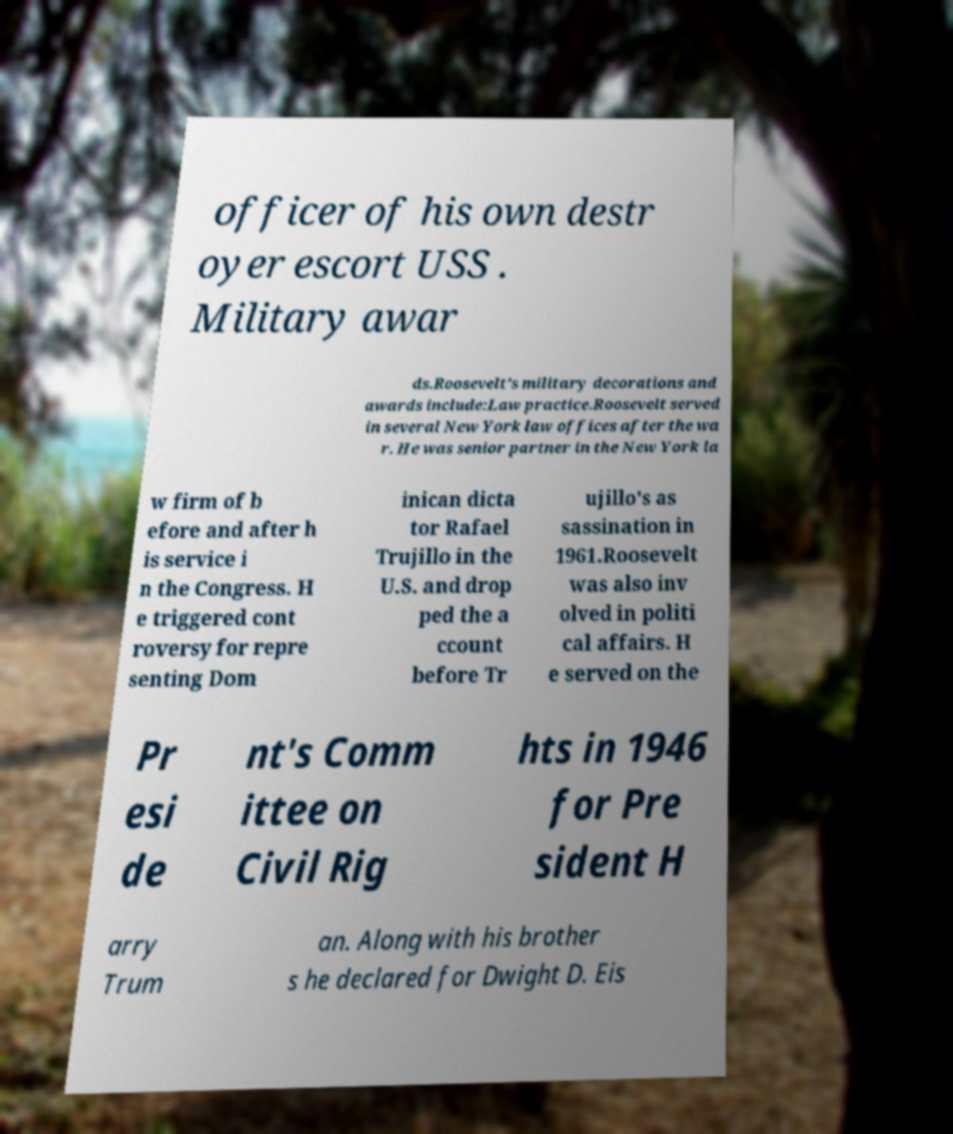What messages or text are displayed in this image? I need them in a readable, typed format. officer of his own destr oyer escort USS . Military awar ds.Roosevelt's military decorations and awards include:Law practice.Roosevelt served in several New York law offices after the wa r. He was senior partner in the New York la w firm of b efore and after h is service i n the Congress. H e triggered cont roversy for repre senting Dom inican dicta tor Rafael Trujillo in the U.S. and drop ped the a ccount before Tr ujillo's as sassination in 1961.Roosevelt was also inv olved in politi cal affairs. H e served on the Pr esi de nt's Comm ittee on Civil Rig hts in 1946 for Pre sident H arry Trum an. Along with his brother s he declared for Dwight D. Eis 